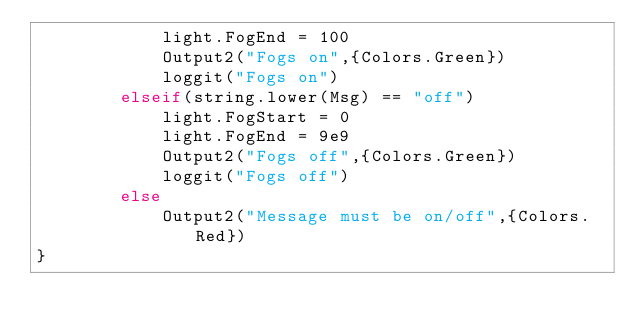<code> <loc_0><loc_0><loc_500><loc_500><_MoonScript_>			light.FogEnd = 100 
			Output2("Fogs on",{Colors.Green})
			loggit("Fogs on")
		elseif(string.lower(Msg) == "off")
			light.FogStart = 0 
			light.FogEnd = 9e9
			Output2("Fogs off",{Colors.Green})
			loggit("Fogs off")
		else 
			Output2("Message must be on/off",{Colors.Red})
}</code> 